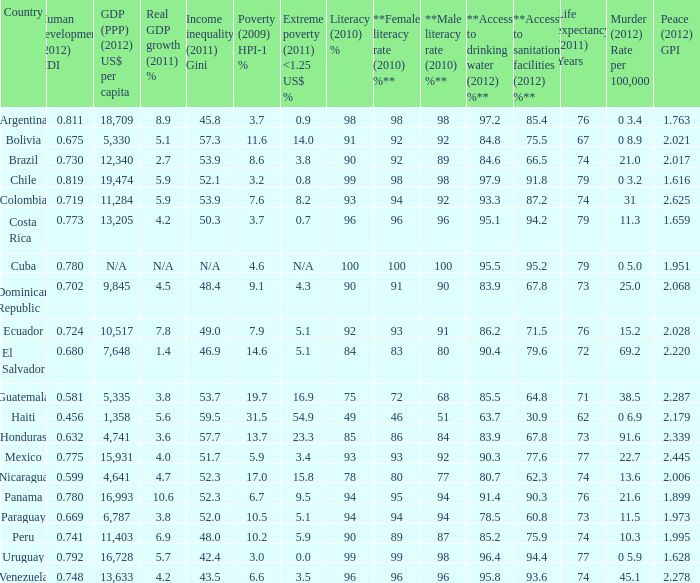What murder (2012) rate per 100,00 also has a 1.616 as the peace (2012) GPI? 0 3.2. 